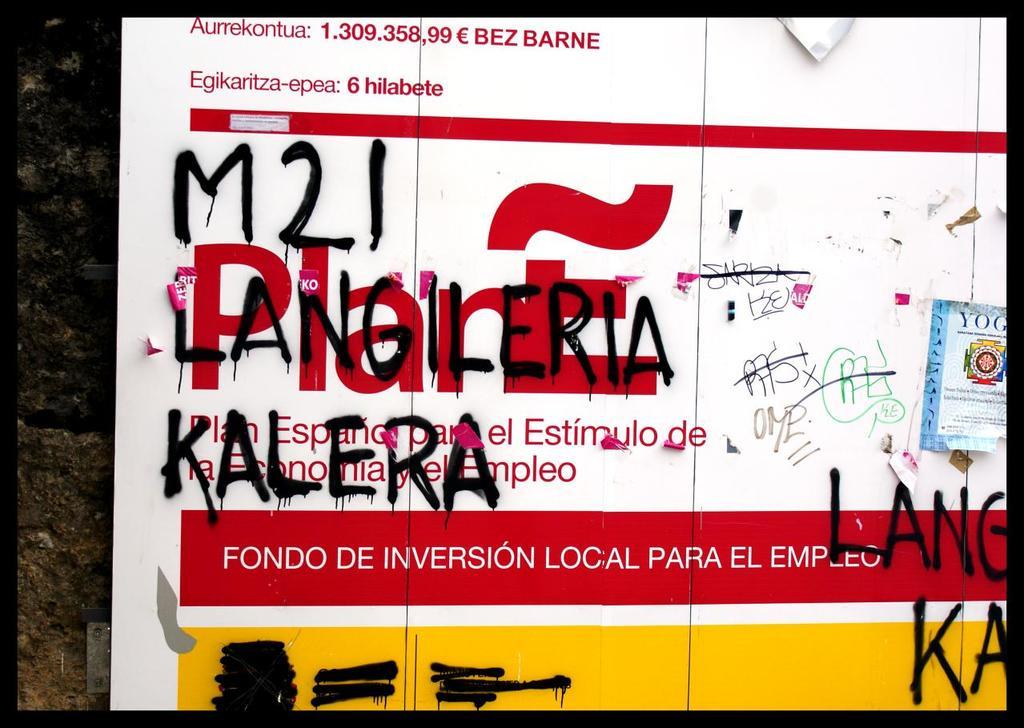This is a switch box?
Make the answer very short. Unanswerable. 